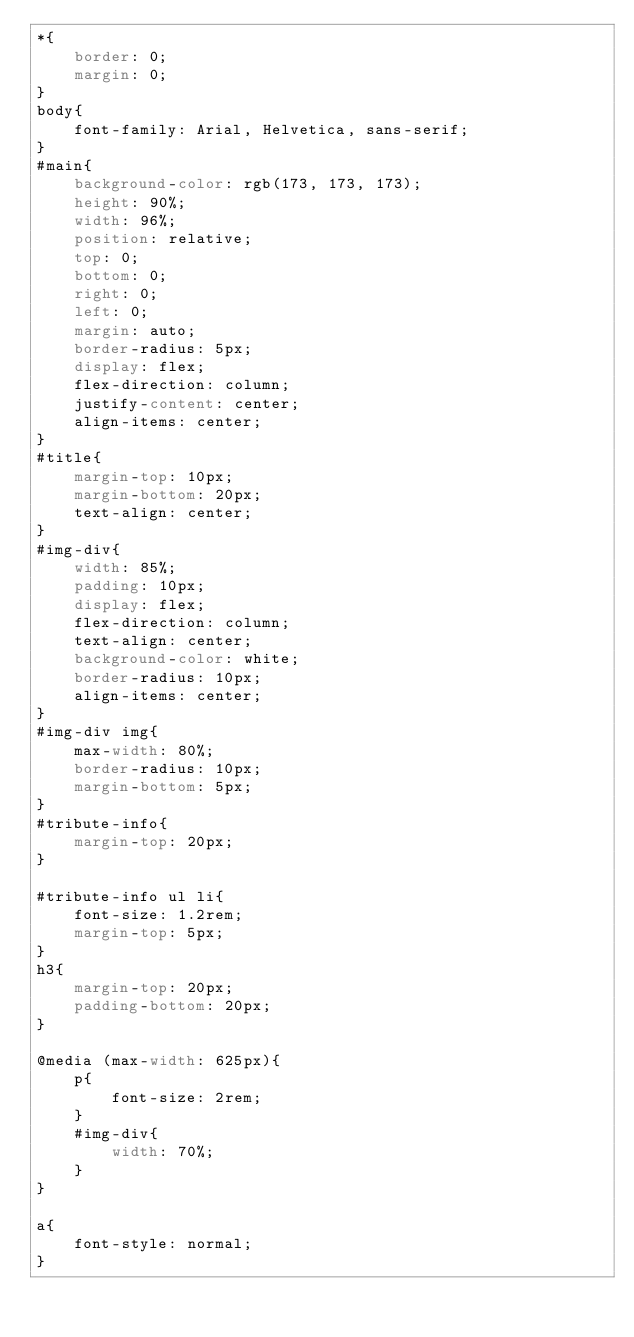<code> <loc_0><loc_0><loc_500><loc_500><_CSS_>*{
    border: 0;
    margin: 0;
}
body{
    font-family: Arial, Helvetica, sans-serif;
}
#main{
    background-color: rgb(173, 173, 173);
    height: 90%;
    width: 96%;
    position: relative;
    top: 0;
    bottom: 0;
    right: 0;
    left: 0;
    margin: auto;
    border-radius: 5px;
    display: flex;
    flex-direction: column;
    justify-content: center;
    align-items: center;
}
#title{
    margin-top: 10px;
    margin-bottom: 20px;
    text-align: center;
}
#img-div{
    width: 85%;
    padding: 10px;
    display: flex;
    flex-direction: column;
    text-align: center;
    background-color: white;
    border-radius: 10px;
    align-items: center;
}
#img-div img{
    max-width: 80%;
    border-radius: 10px;
    margin-bottom: 5px;
}
#tribute-info{
    margin-top: 20px;
}

#tribute-info ul li{
    font-size: 1.2rem;
    margin-top: 5px;
}
h3{
    margin-top: 20px;
    padding-bottom: 20px;
}

@media (max-width: 625px){
    p{
        font-size: 2rem;
    }
    #img-div{
        width: 70%;
    }
}

a{
    font-style: normal;
}</code> 